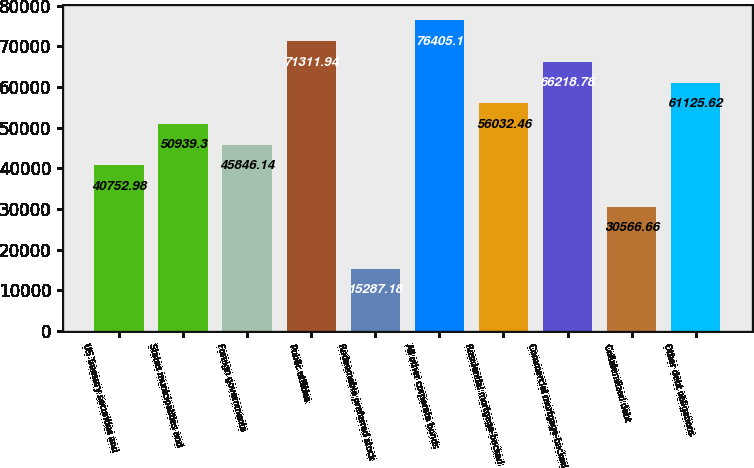Convert chart. <chart><loc_0><loc_0><loc_500><loc_500><bar_chart><fcel>US Treasury securities and<fcel>States municipalities and<fcel>Foreign governments<fcel>Public utilities<fcel>Redeemable preferred stock<fcel>All other corporate bonds<fcel>Residential mortgage-backed<fcel>Commercial mortgage-backed<fcel>Collateralized debt<fcel>Other debt obligations<nl><fcel>40753<fcel>50939.3<fcel>45846.1<fcel>71311.9<fcel>15287.2<fcel>76405.1<fcel>56032.5<fcel>66218.8<fcel>30566.7<fcel>61125.6<nl></chart> 